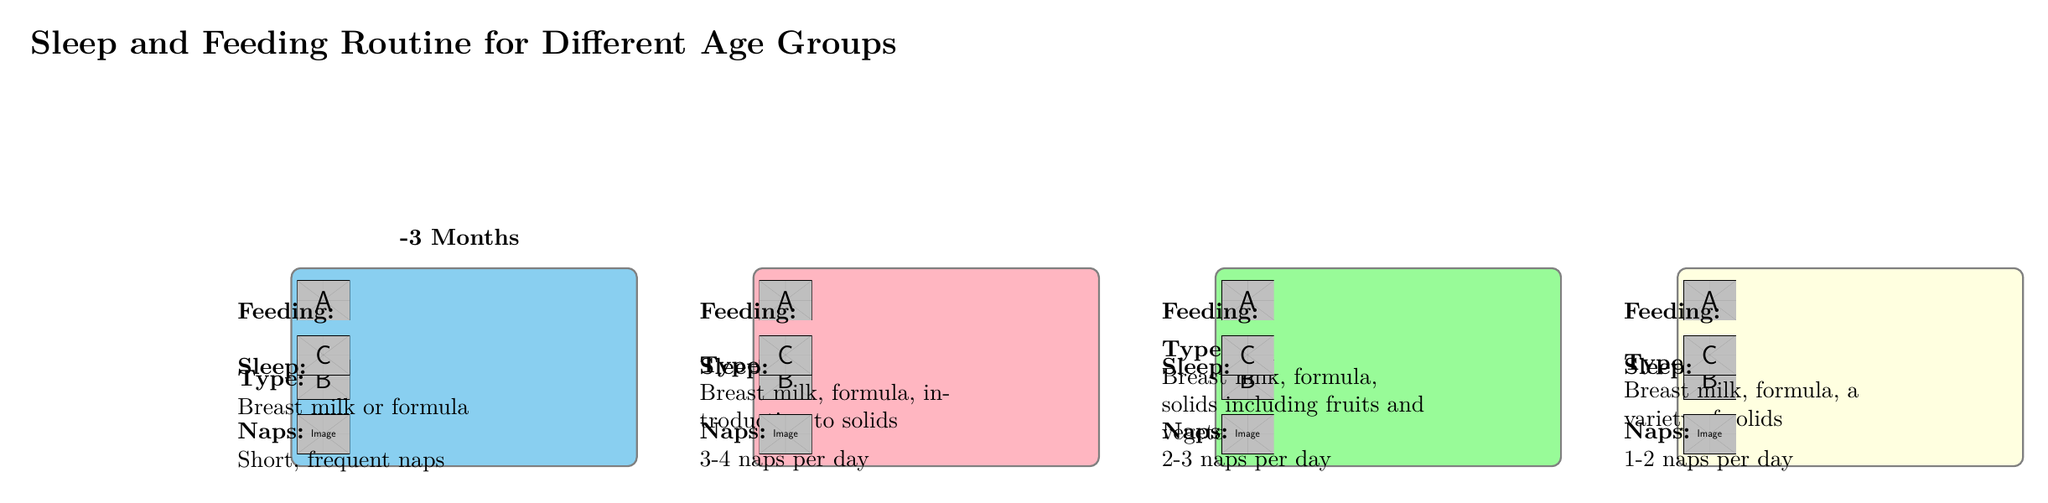What is the feeding frequency for infants aged 0-3 months? The diagram indicates that infants in the 0-3 months age group need to be fed 8-12 times a day. This is directly stated under the feeding information for that age group.
Answer: 8-12 times a day How many hours do infants aged 4-6 months typically sleep? The sleep duration for the 4-6 months age group is displayed in the diagram as 12-16 hours per day, found in the sleep section for that specific age group.
Answer: 12-16 hours per day What type of food is introduced for infants aged 7-9 months? For infants aged 7-9 months, the diagram specifies that they are introduced to "Breast milk, formula, solids including fruits and vegetables." This information is clearly outlined under the type of food for that age group.
Answer: Breast milk, formula, solids including fruits and vegetables How many naps do infants aged 10-12 months usually take? The diagram shows that infants aged 10-12 months generally have 1-2 naps per day, which is indicated in the naps section for that age group.
Answer: 1-2 naps per day What is the total sleep duration for infants aged 0-3 months? The diagram states that infants aged 0-3 months sleep for 14-17 hours per day. This total sleep duration is listed specifically under the sleep section for that age group.
Answer: 14-17 hours per day Which age group has the least feeding frequency? By comparing the feeding frequencies across all age groups in the diagram, the 10-12 months age group has the least frequency of 3-4 times a day. This requires synthesizing feeding information across the various groups to determine the least.
Answer: 3-4 times a day What is the trend in sleep hours as infants grow from 0-3 months to 10-12 months? Analyzing the sleep data across the age groups reveals a decrease from 14-17 hours for 0-3 months to 12-14 hours for 10-12 months, showing that sleep duration generally decreases as infants age.
Answer: Decrease Which age group is the only one that mentions the introduction to solids? The 4-6 months and 7-9 months groups both mention the introduction to solids, indicating that a variety of solid foods starts at this age. The question must be carefully examined to note the range from 4-9 months includes solid foods.
Answer: 4-6 months, 7-9 months 